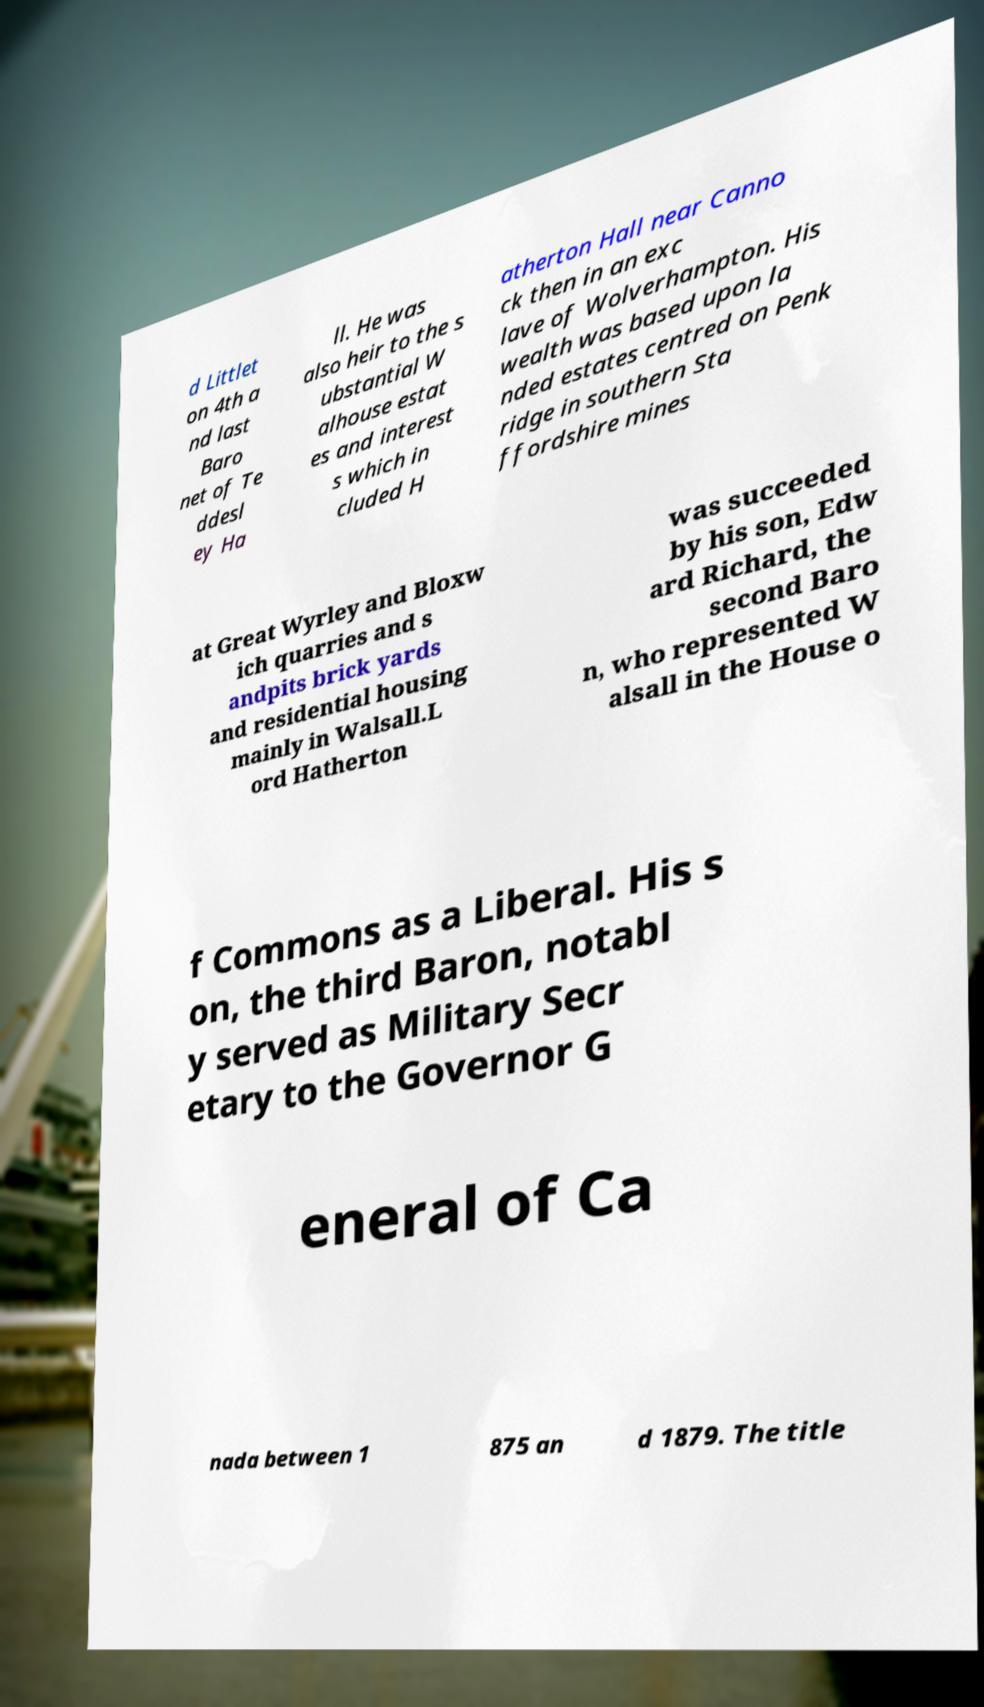I need the written content from this picture converted into text. Can you do that? d Littlet on 4th a nd last Baro net of Te ddesl ey Ha ll. He was also heir to the s ubstantial W alhouse estat es and interest s which in cluded H atherton Hall near Canno ck then in an exc lave of Wolverhampton. His wealth was based upon la nded estates centred on Penk ridge in southern Sta ffordshire mines at Great Wyrley and Bloxw ich quarries and s andpits brick yards and residential housing mainly in Walsall.L ord Hatherton was succeeded by his son, Edw ard Richard, the second Baro n, who represented W alsall in the House o f Commons as a Liberal. His s on, the third Baron, notabl y served as Military Secr etary to the Governor G eneral of Ca nada between 1 875 an d 1879. The title 